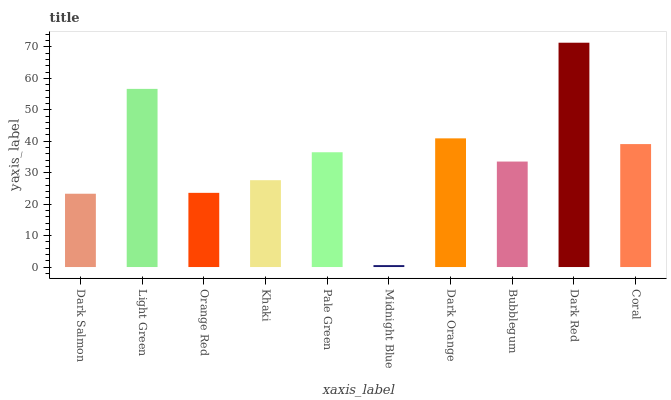Is Midnight Blue the minimum?
Answer yes or no. Yes. Is Dark Red the maximum?
Answer yes or no. Yes. Is Light Green the minimum?
Answer yes or no. No. Is Light Green the maximum?
Answer yes or no. No. Is Light Green greater than Dark Salmon?
Answer yes or no. Yes. Is Dark Salmon less than Light Green?
Answer yes or no. Yes. Is Dark Salmon greater than Light Green?
Answer yes or no. No. Is Light Green less than Dark Salmon?
Answer yes or no. No. Is Pale Green the high median?
Answer yes or no. Yes. Is Bubblegum the low median?
Answer yes or no. Yes. Is Orange Red the high median?
Answer yes or no. No. Is Midnight Blue the low median?
Answer yes or no. No. 